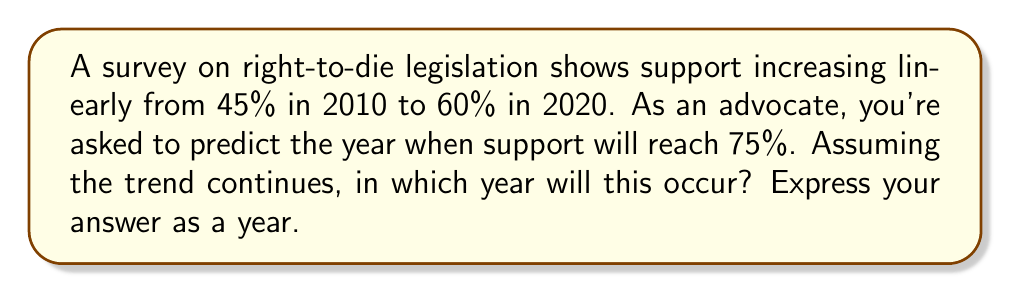What is the answer to this math problem? Let's approach this step-by-step:

1) First, we need to calculate the rate of change in public opinion.

   Change in support: $60\% - 45\% = 15\%$
   Time period: $2020 - 2010 = 10$ years
   
   Rate of change: $\frac{15\%}{10 \text{ years}} = 1.5\%$ per year

2) Now, we need to determine how much more support is needed to reach 75%:

   $75\% - 60\% = 15\%$ additional support needed

3) To find how many years this will take, we divide the additional support needed by the rate of change:

   $\frac{15\%}{1.5\% \text{ per year}} = 10$ years

4) Since the last data point is from 2020, we add 10 years to 2020:

   $2020 + 10 = 2030$

Therefore, if the trend continues linearly, support for right-to-die legislation will reach 75% in 2030.
Answer: 2030 